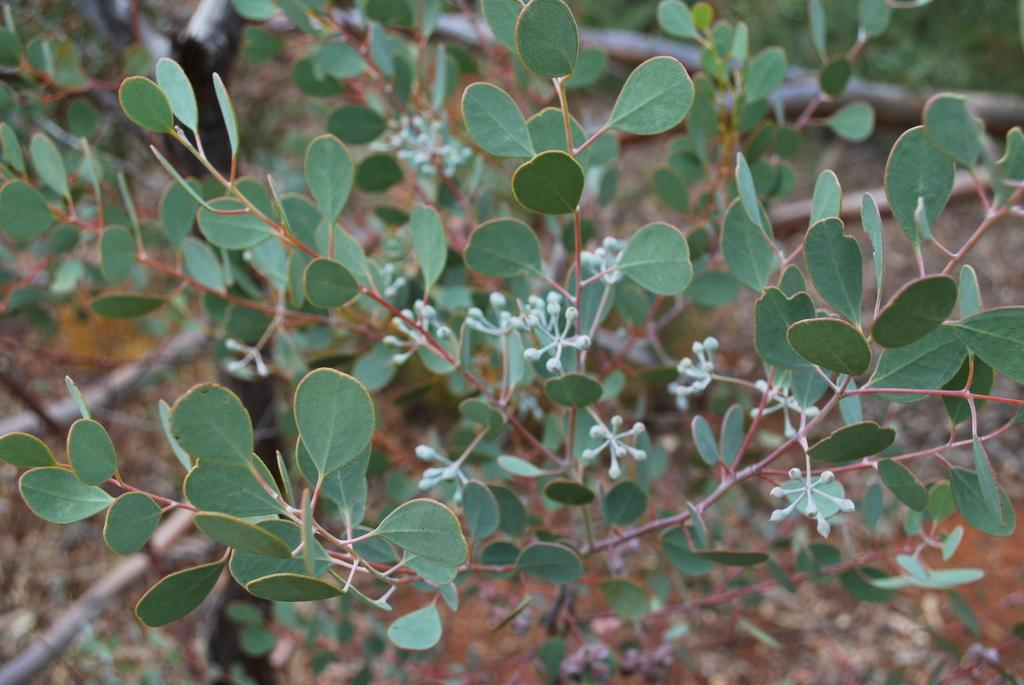What type of living organisms can be seen on the ground in the image? There are plants on the ground in the image. Can you see any jellyfish swimming in the image? There are no jellyfish present in the image; it features plants on the ground. What type of worm can be seen crawling among the plants in the image? There are no worms present in the image; it only features plants on the ground. 